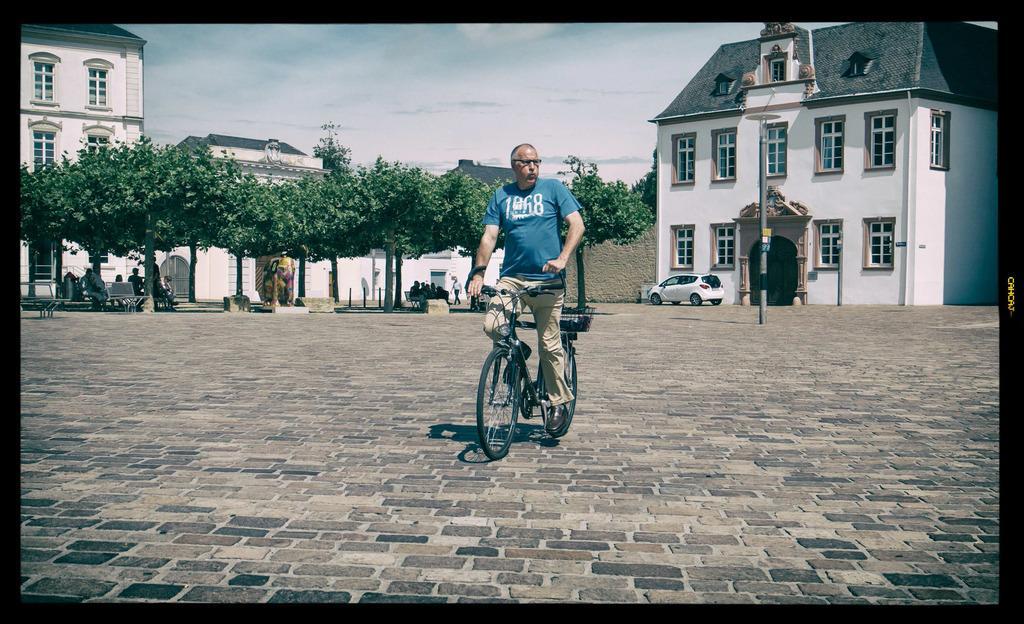Describe this image in one or two sentences. This picture is clicked outside the city. There is a man wearing blue t-shirt is riding bicycle. Behind him, we see a building in white color. In front of the building, we see a white car and beside him, we see trees and under the trees, we see people sitting on the bench. On the left corner of the picture, we see a white building and beside, on the top of the picture, we see sky. 